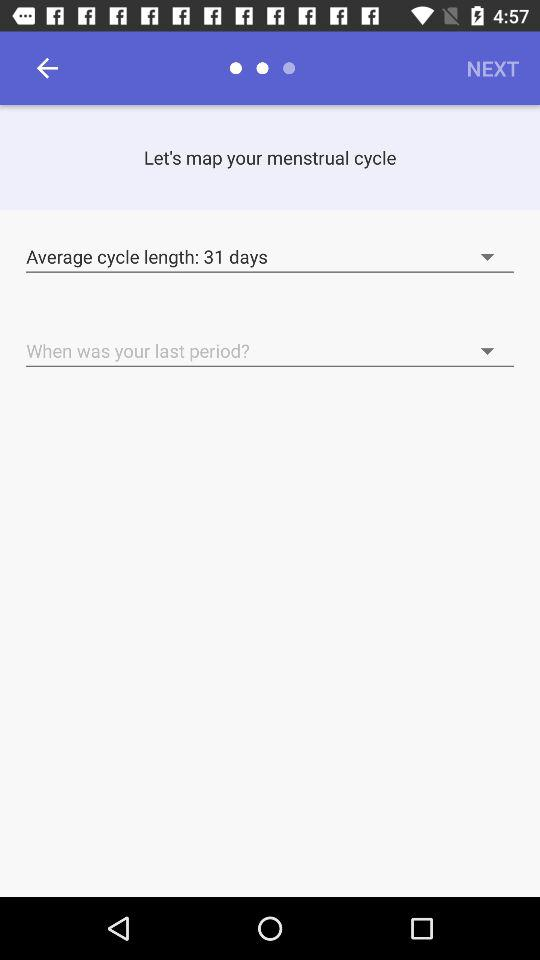Which date is selected for the last period?
When the provided information is insufficient, respond with <no answer>. <no answer> 